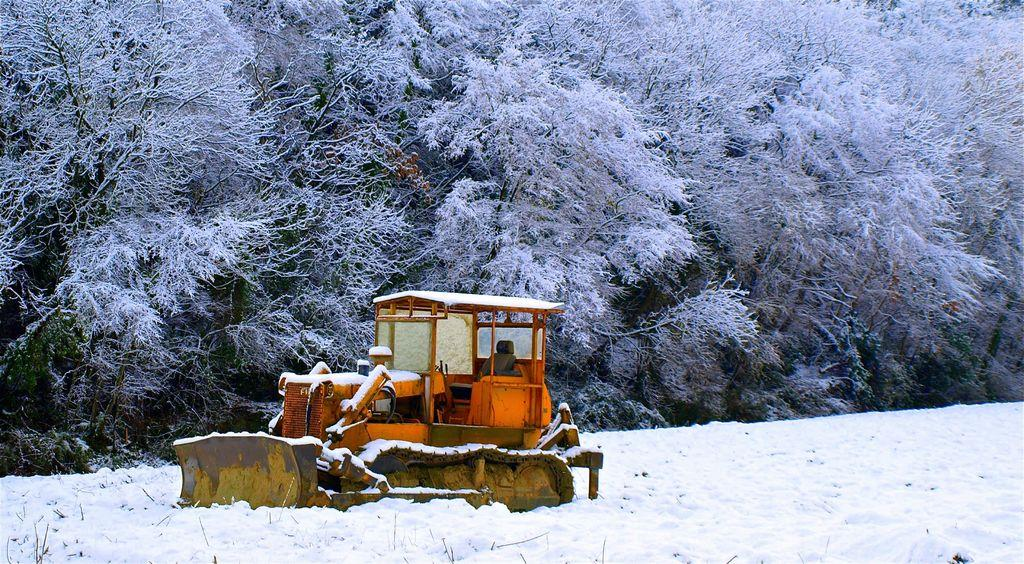What is the main subject of the image? There is a bulldozer in the middle of the image. What is the weather condition in the image? There is snow visible in the image. What can be seen in the background of the image? There are trees in the background of the image. Can you see any giants in the image? No, there are no giants present in the image. What type of band is playing in the background of the image? There is no band present in the image; it features a bulldozer in the snow with trees in the background. 